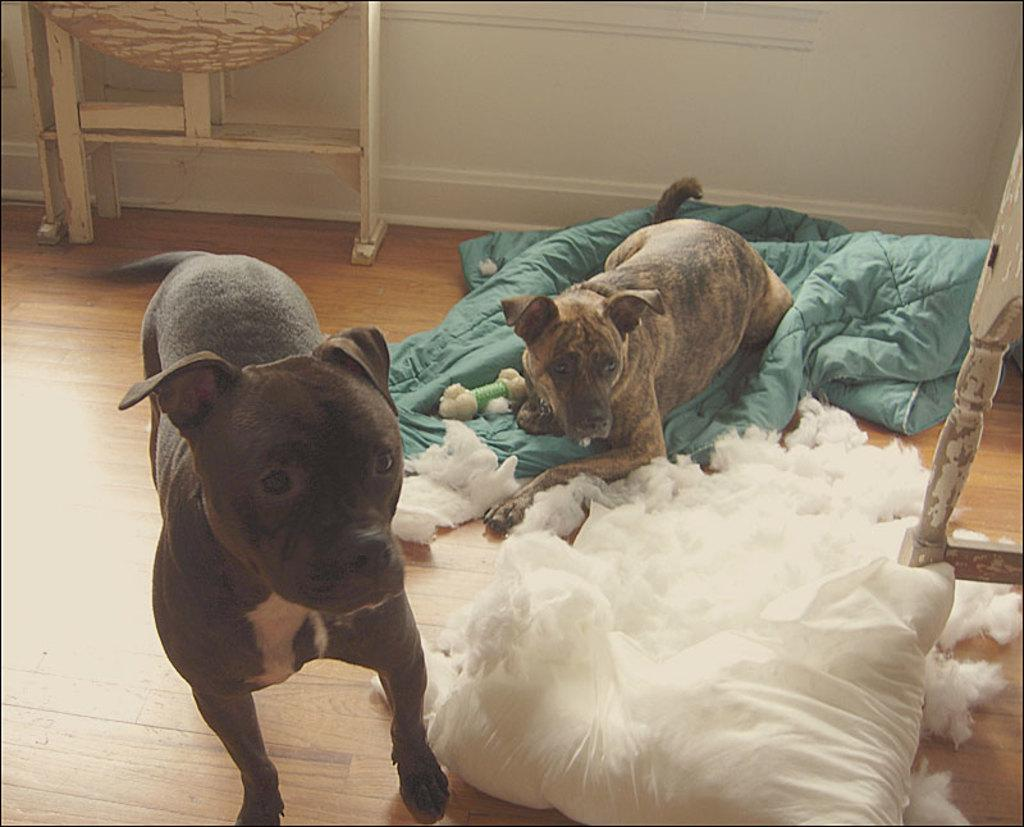How many dogs are in the image? There are two dogs in the image. What is one of the dogs doing in the image? One of the dogs is on clothes. What type of material is present in the image? There is cotton in the image. What else can be seen in the image besides the dogs and cotton? There are other objects in the image. What is visible in the background of the image? There is a wall in the background of the image. How many fingers can be seen on the dogs' paws in the image? Dogs do not have fingers; they have paws with toes. --- Facts: 1. There is a person holding a book in the image. 2. The book has a blue cover. 3. The person is sitting on a chair. 4. There is a table in the image. 5. The table has a lamp on it. Absurd Topics: elephant, ocean, bicycle Conversation: What is the person in the image holding? The person is holding a book in the image. What color is the book's cover? The book has a blue cover. Where is the person sitting? The person is sitting on a chair. What else can be seen in the image besides the person and the book? There is a table in the image. What is on the table in the image? The table has a lamp on it. Reasoning: Let's think step by step in order to produce the conversation. We start by identifying the main subject in the image, which is the person holding a book. Then, we describe the book's cover color, which is blue. Next, we mention the person's position, noting that they are sitting on a chair. We then acknowledge the presence of a table in the image, and finally, we describe what is on the table, which is a lamp. Absurd Question/Answer: Can you see an elephant swimming in the ocean in the image? No, there is no elephant or ocean present in the image. 